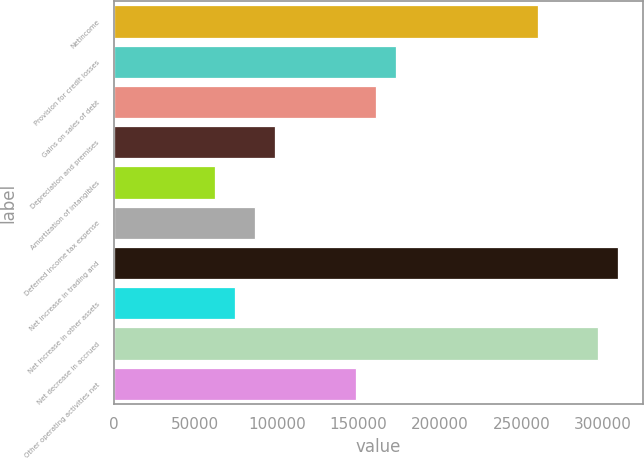Convert chart to OTSL. <chart><loc_0><loc_0><loc_500><loc_500><bar_chart><fcel>Netincome<fcel>Provision for credit losses<fcel>Gains on sales of debt<fcel>Depreciation and premises<fcel>Amortization of intangibles<fcel>Deferred income tax expense<fcel>Net increase in trading and<fcel>Net increase in other assets<fcel>Net decrease in accrued<fcel>Other operating activities net<nl><fcel>259914<fcel>173277<fcel>160901<fcel>99017.8<fcel>61888<fcel>86641.2<fcel>309420<fcel>74264.6<fcel>297043<fcel>148524<nl></chart> 